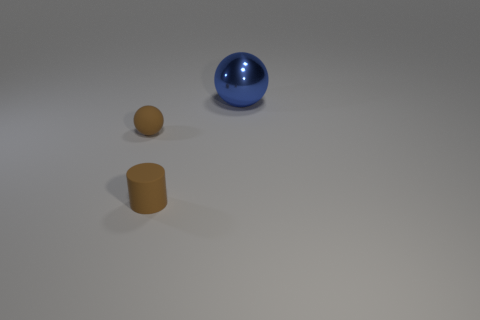Are there any other things that have the same shape as the metallic object?
Provide a short and direct response. Yes. What number of rubber things are brown cylinders or small green spheres?
Offer a terse response. 1. Is the number of brown matte things that are behind the small brown sphere less than the number of blue spheres?
Give a very brief answer. Yes. The brown object to the left of the brown matte thing in front of the ball in front of the big blue shiny sphere is what shape?
Ensure brevity in your answer.  Sphere. Is the big sphere the same color as the rubber ball?
Provide a succinct answer. No. Are there more tiny brown spheres than blue rubber cubes?
Your response must be concise. Yes. How many other things are made of the same material as the cylinder?
Make the answer very short. 1. How many objects are large red cylinders or spheres on the left side of the blue metal ball?
Your answer should be very brief. 1. Is the number of big gray blocks less than the number of metal things?
Provide a succinct answer. Yes. What is the color of the tiny thing on the left side of the rubber thing that is in front of the sphere left of the big object?
Make the answer very short. Brown. 